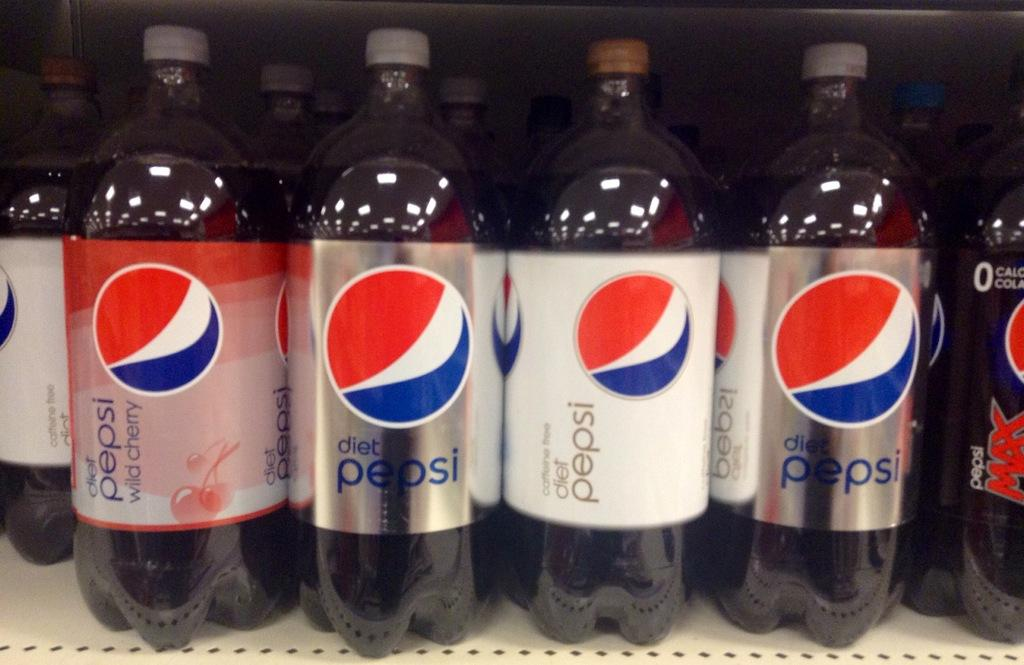What is the main subject of the image? The main subject of the image is a shelf. What can be seen on the shelf? There are Pepsi bottles on the shelf. What type of crown is being advertised on the shelf? There is no crown being advertised on the shelf; the image only shows Pepsi bottles on a shelf. 